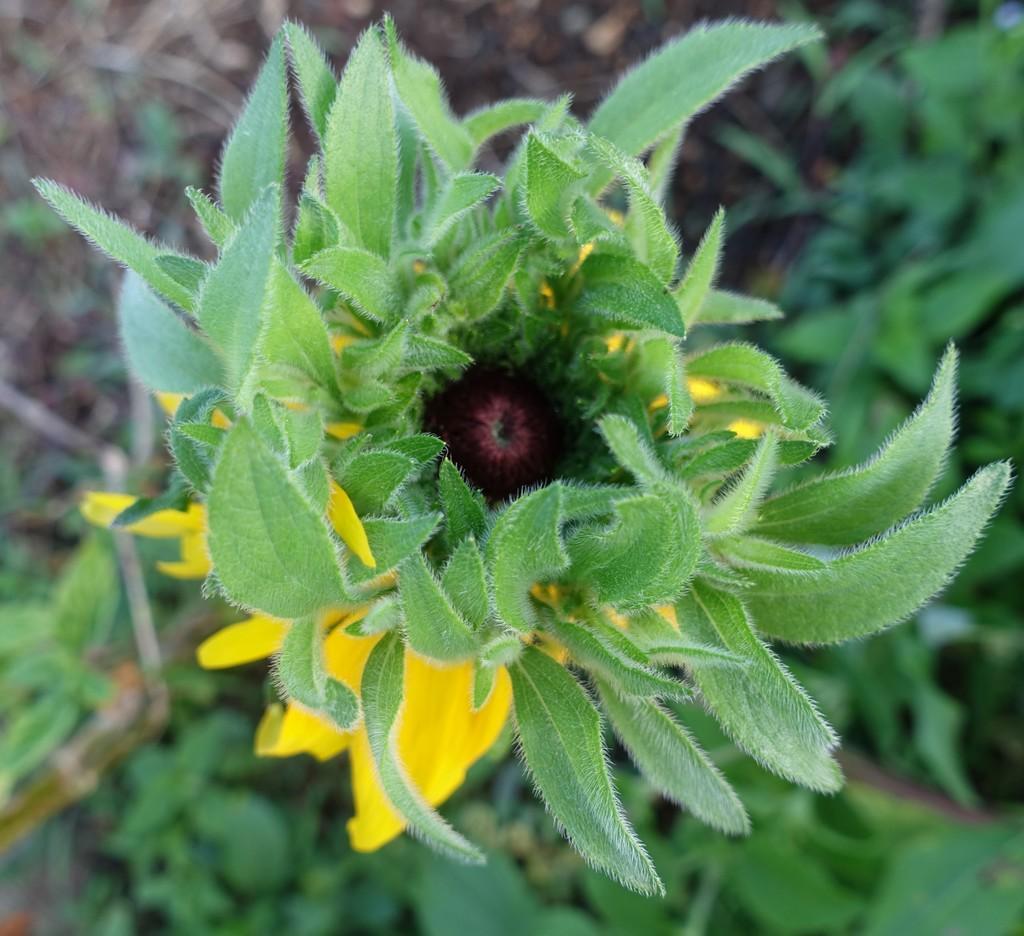Could you give a brief overview of what you see in this image? In this image I can see a plant along with the flowers and leaves. The petals are in yellow color. At the bottom few leaves are visible. At the top, I can see the ground. 